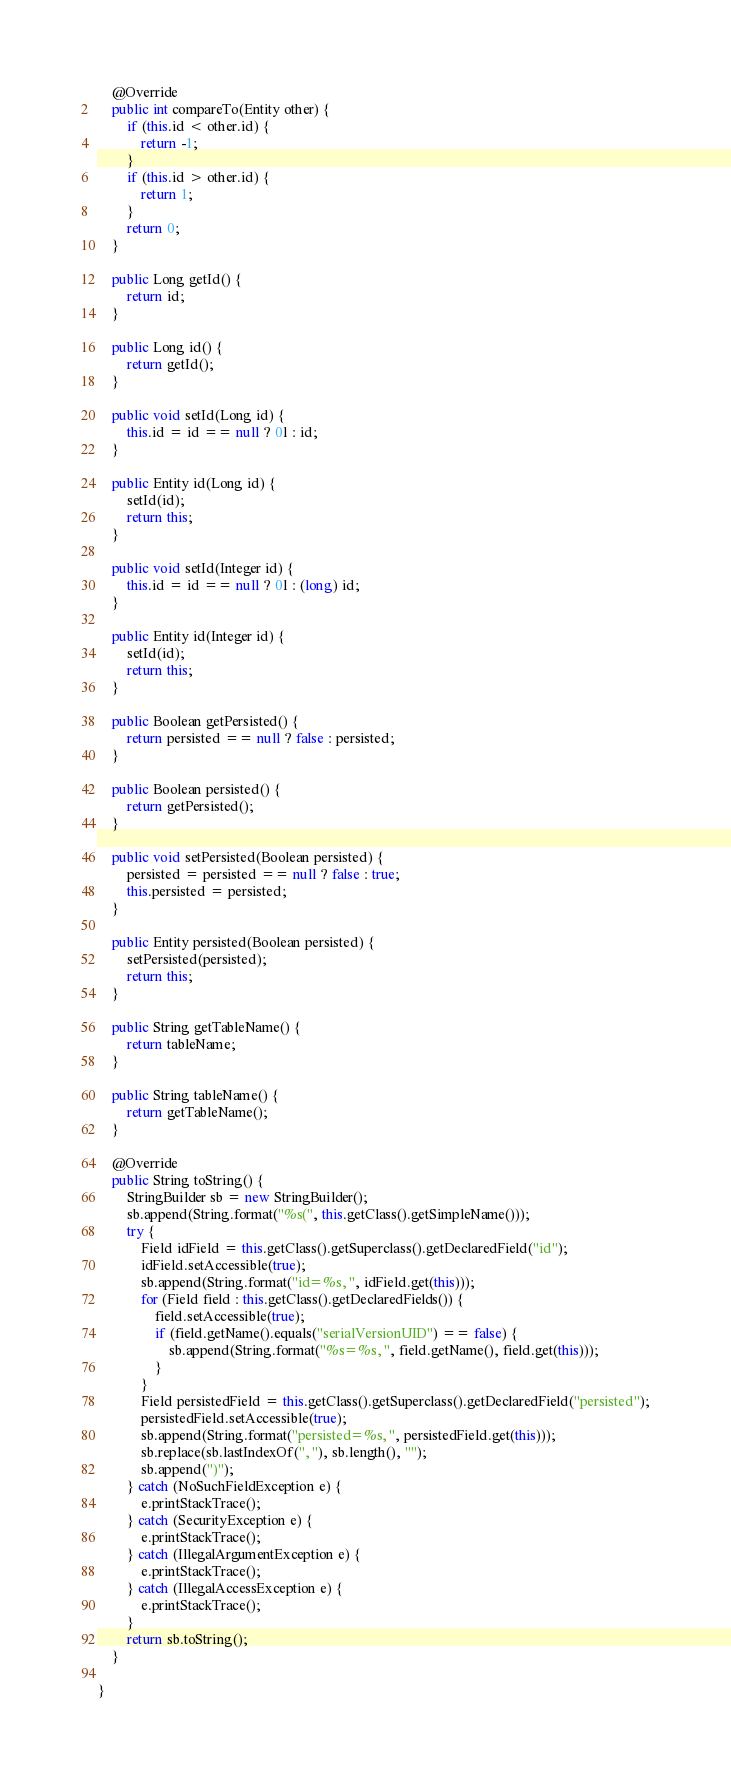<code> <loc_0><loc_0><loc_500><loc_500><_Java_>
    @Override
    public int compareTo(Entity other) {
        if (this.id < other.id) {
            return -1;
        }
        if (this.id > other.id) {
            return 1;
        }
        return 0;
    }

    public Long getId() {
        return id;
    }

    public Long id() {
        return getId();
    }

    public void setId(Long id) {
        this.id = id == null ? 0l : id;
    }

    public Entity id(Long id) {
        setId(id);
        return this;
    }

    public void setId(Integer id) {
        this.id = id == null ? 0l : (long) id;
    }

    public Entity id(Integer id) {
        setId(id);
        return this;
    }

    public Boolean getPersisted() {
        return persisted == null ? false : persisted;
    }

    public Boolean persisted() {
        return getPersisted();
    }

    public void setPersisted(Boolean persisted) {
        persisted = persisted == null ? false : true;
        this.persisted = persisted;
    }

    public Entity persisted(Boolean persisted) {
        setPersisted(persisted);
        return this;
    }

    public String getTableName() {
        return tableName;
    }

    public String tableName() {
        return getTableName();
    }

    @Override
    public String toString() {
        StringBuilder sb = new StringBuilder();
        sb.append(String.format("%s(", this.getClass().getSimpleName()));
        try {
            Field idField = this.getClass().getSuperclass().getDeclaredField("id");
            idField.setAccessible(true);
            sb.append(String.format("id=%s, ", idField.get(this)));
            for (Field field : this.getClass().getDeclaredFields()) {
                field.setAccessible(true);
                if (field.getName().equals("serialVersionUID") == false) {
                    sb.append(String.format("%s=%s, ", field.getName(), field.get(this)));
                }
            }
            Field persistedField = this.getClass().getSuperclass().getDeclaredField("persisted");
            persistedField.setAccessible(true);
            sb.append(String.format("persisted=%s, ", persistedField.get(this)));
            sb.replace(sb.lastIndexOf(", "), sb.length(), "");
            sb.append(")");
        } catch (NoSuchFieldException e) {
            e.printStackTrace();
        } catch (SecurityException e) {
            e.printStackTrace();
        } catch (IllegalArgumentException e) {
            e.printStackTrace();
        } catch (IllegalAccessException e) {
            e.printStackTrace();
        }
        return sb.toString();
    }

}</code> 